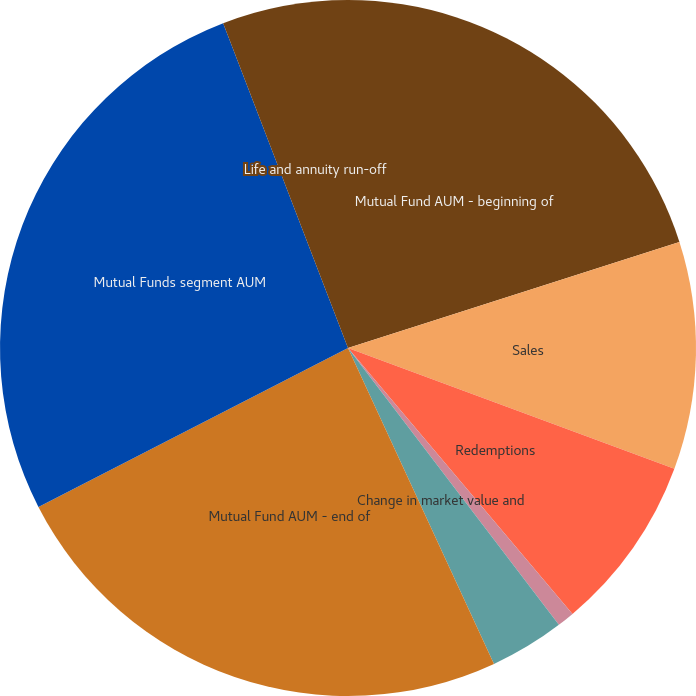Convert chart to OTSL. <chart><loc_0><loc_0><loc_500><loc_500><pie_chart><fcel>Mutual Fund AUM - beginning of<fcel>Sales<fcel>Redemptions<fcel>Net Flows<fcel>Change in market value and<fcel>Mutual Fund AUM - end of<fcel>Mutual Funds segment AUM<fcel>Life and annuity run-off<nl><fcel>20.07%<fcel>10.57%<fcel>8.2%<fcel>0.8%<fcel>3.47%<fcel>24.34%<fcel>26.71%<fcel>5.84%<nl></chart> 